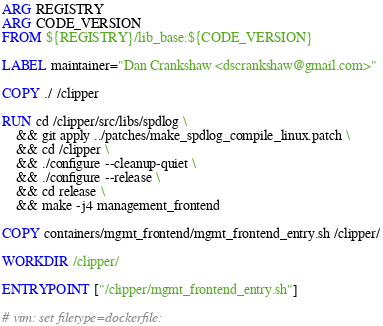<code> <loc_0><loc_0><loc_500><loc_500><_Dockerfile_>ARG REGISTRY
ARG CODE_VERSION
FROM ${REGISTRY}/lib_base:${CODE_VERSION}

LABEL maintainer="Dan Crankshaw <dscrankshaw@gmail.com>"

COPY ./ /clipper

RUN cd /clipper/src/libs/spdlog \
    && git apply ../patches/make_spdlog_compile_linux.patch \
    && cd /clipper \
    && ./configure --cleanup-quiet \
    && ./configure --release \
    && cd release \
    && make -j4 management_frontend

COPY containers/mgmt_frontend/mgmt_frontend_entry.sh /clipper/

WORKDIR /clipper/

ENTRYPOINT ["/clipper/mgmt_frontend_entry.sh"]

# vim: set filetype=dockerfile:
</code> 